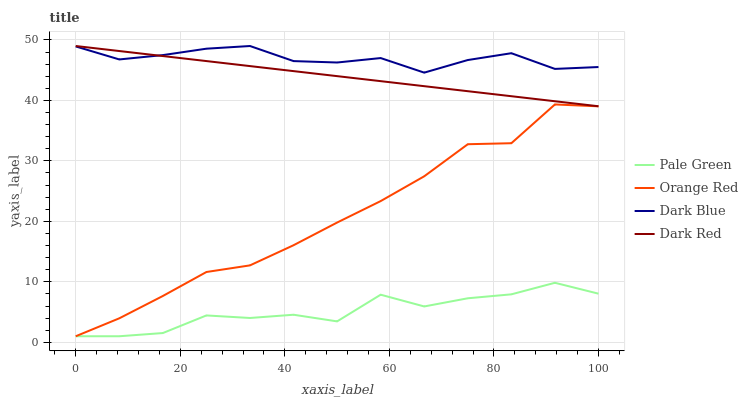Does Pale Green have the minimum area under the curve?
Answer yes or no. Yes. Does Dark Blue have the maximum area under the curve?
Answer yes or no. Yes. Does Orange Red have the minimum area under the curve?
Answer yes or no. No. Does Orange Red have the maximum area under the curve?
Answer yes or no. No. Is Dark Red the smoothest?
Answer yes or no. Yes. Is Pale Green the roughest?
Answer yes or no. Yes. Is Orange Red the smoothest?
Answer yes or no. No. Is Orange Red the roughest?
Answer yes or no. No. Does Pale Green have the lowest value?
Answer yes or no. Yes. Does Dark Red have the lowest value?
Answer yes or no. No. Does Dark Red have the highest value?
Answer yes or no. Yes. Does Orange Red have the highest value?
Answer yes or no. No. Is Orange Red less than Dark Blue?
Answer yes or no. Yes. Is Dark Red greater than Pale Green?
Answer yes or no. Yes. Does Dark Red intersect Dark Blue?
Answer yes or no. Yes. Is Dark Red less than Dark Blue?
Answer yes or no. No. Is Dark Red greater than Dark Blue?
Answer yes or no. No. Does Orange Red intersect Dark Blue?
Answer yes or no. No. 